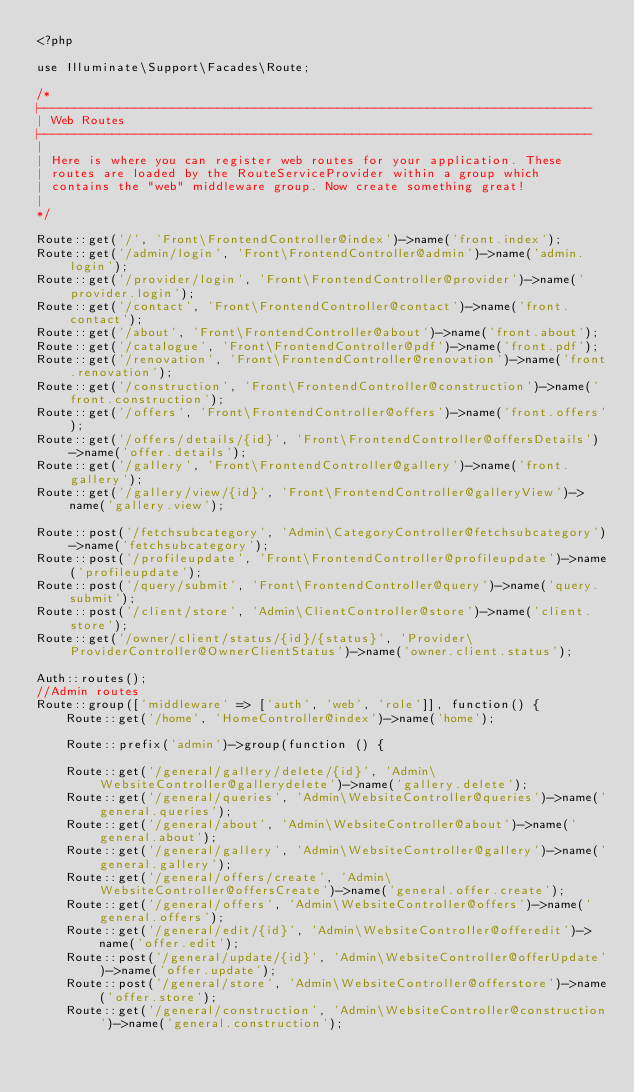Convert code to text. <code><loc_0><loc_0><loc_500><loc_500><_PHP_><?php

use Illuminate\Support\Facades\Route;

/*
|--------------------------------------------------------------------------
| Web Routes
|--------------------------------------------------------------------------
|
| Here is where you can register web routes for your application. These
| routes are loaded by the RouteServiceProvider within a group which
| contains the "web" middleware group. Now create something great!
|
*/

Route::get('/', 'Front\FrontendController@index')->name('front.index');
Route::get('/admin/login', 'Front\FrontendController@admin')->name('admin.login');
Route::get('/provider/login', 'Front\FrontendController@provider')->name('provider.login');
Route::get('/contact', 'Front\FrontendController@contact')->name('front.contact');
Route::get('/about', 'Front\FrontendController@about')->name('front.about');
Route::get('/catalogue', 'Front\FrontendController@pdf')->name('front.pdf');
Route::get('/renovation', 'Front\FrontendController@renovation')->name('front.renovation');
Route::get('/construction', 'Front\FrontendController@construction')->name('front.construction');
Route::get('/offers', 'Front\FrontendController@offers')->name('front.offers');
Route::get('/offers/details/{id}', 'Front\FrontendController@offersDetails')->name('offer.details');
Route::get('/gallery', 'Front\FrontendController@gallery')->name('front.gallery');
Route::get('/gallery/view/{id}', 'Front\FrontendController@galleryView')->name('gallery.view');

Route::post('/fetchsubcategory', 'Admin\CategoryController@fetchsubcategory')->name('fetchsubcategory');
Route::post('/profileupdate', 'Front\FrontendController@profileupdate')->name('profileupdate');
Route::post('/query/submit', 'Front\FrontendController@query')->name('query.submit');
Route::post('/client/store', 'Admin\ClientController@store')->name('client.store');
Route::get('/owner/client/status/{id}/{status}', 'Provider\ProviderController@OwnerClientStatus')->name('owner.client.status');

Auth::routes();
//Admin routes
Route::group(['middleware' => ['auth', 'web', 'role']], function() {
    Route::get('/home', 'HomeController@index')->name('home');

    Route::prefix('admin')->group(function () {

    Route::get('/general/gallery/delete/{id}', 'Admin\WebsiteController@gallerydelete')->name('gallery.delete');
    Route::get('/general/queries', 'Admin\WebsiteController@queries')->name('general.queries');
    Route::get('/general/about', 'Admin\WebsiteController@about')->name('general.about');
    Route::get('/general/gallery', 'Admin\WebsiteController@gallery')->name('general.gallery');
    Route::get('/general/offers/create', 'Admin\WebsiteController@offersCreate')->name('general.offer.create');
    Route::get('/general/offers', 'Admin\WebsiteController@offers')->name('general.offers');
    Route::get('/general/edit/{id}', 'Admin\WebsiteController@offeredit')->name('offer.edit');
    Route::post('/general/update/{id}', 'Admin\WebsiteController@offerUpdate')->name('offer.update');
    Route::post('/general/store', 'Admin\WebsiteController@offerstore')->name('offer.store');
    Route::get('/general/construction', 'Admin\WebsiteController@construction')->name('general.construction');</code> 